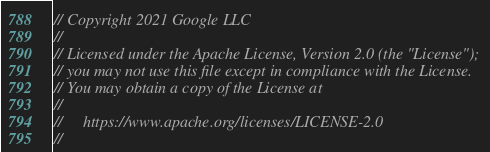Convert code to text. <code><loc_0><loc_0><loc_500><loc_500><_Go_>// Copyright 2021 Google LLC
//
// Licensed under the Apache License, Version 2.0 (the "License");
// you may not use this file except in compliance with the License.
// You may obtain a copy of the License at
//
//     https://www.apache.org/licenses/LICENSE-2.0
//</code> 